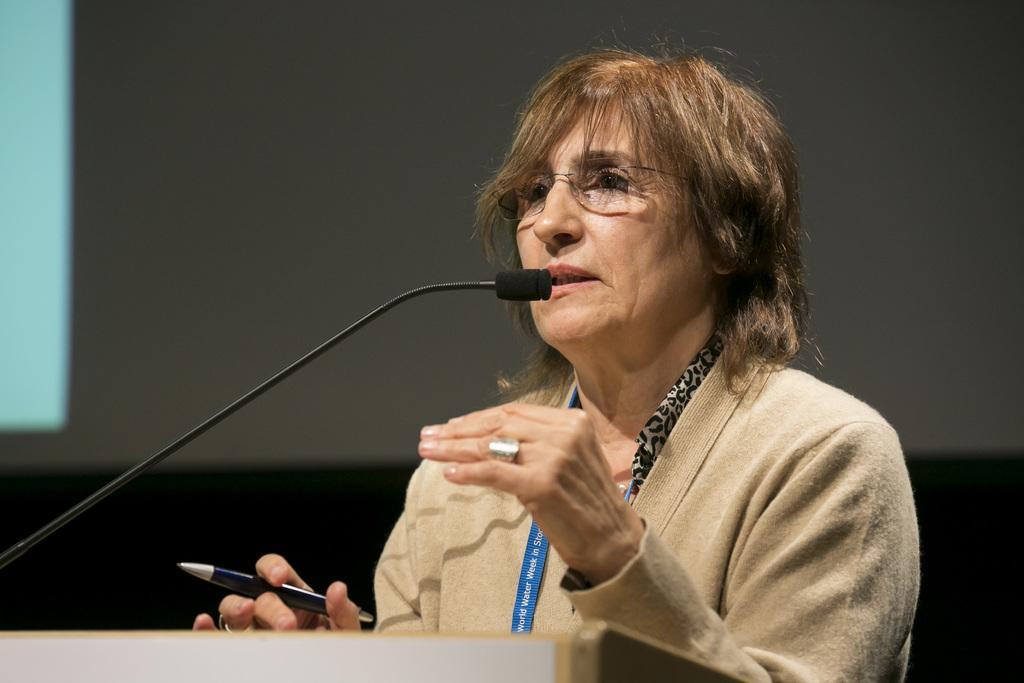Please provide a concise description of this image. In this image there is a woman holding a pen in her hand and standing in front of the podium, on that podium there is mic, in the background it is dark. 